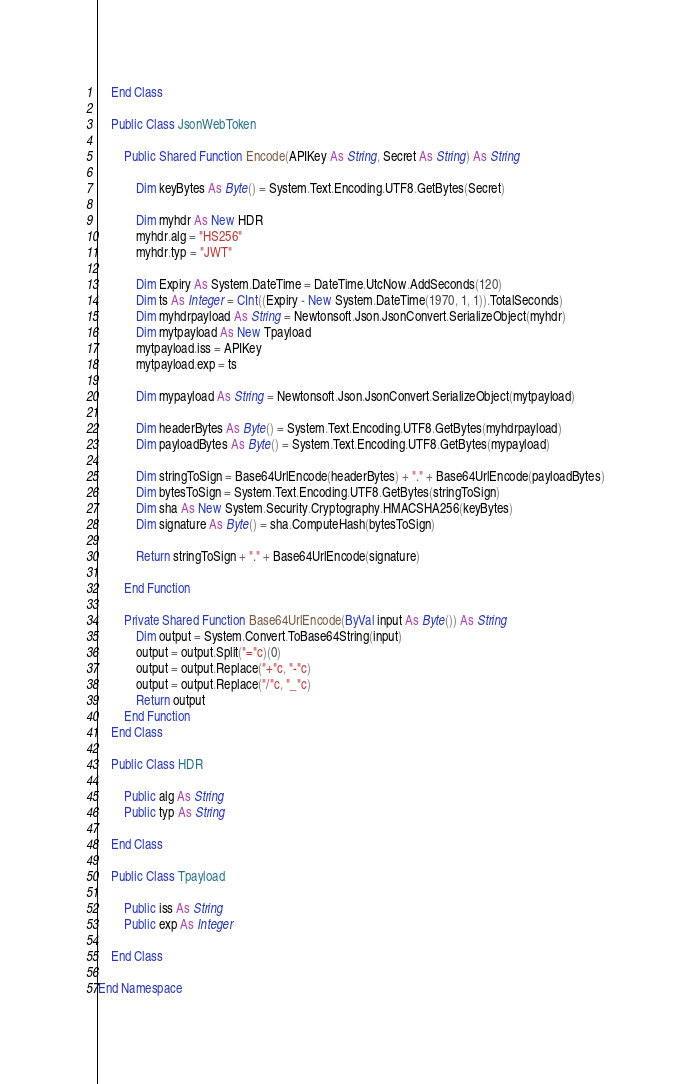<code> <loc_0><loc_0><loc_500><loc_500><_VisualBasic_>
    End Class

    Public Class JsonWebToken

        Public Shared Function Encode(APIKey As String, Secret As String) As String

            Dim keyBytes As Byte() = System.Text.Encoding.UTF8.GetBytes(Secret)

            Dim myhdr As New HDR
            myhdr.alg = "HS256"
            myhdr.typ = "JWT"

            Dim Expiry As System.DateTime = DateTime.UtcNow.AddSeconds(120)
            Dim ts As Integer = CInt((Expiry - New System.DateTime(1970, 1, 1)).TotalSeconds)
            Dim myhdrpayload As String = Newtonsoft.Json.JsonConvert.SerializeObject(myhdr)
            Dim mytpayload As New Tpayload
            mytpayload.iss = APIKey
            mytpayload.exp = ts

            Dim mypayload As String = Newtonsoft.Json.JsonConvert.SerializeObject(mytpayload)

            Dim headerBytes As Byte() = System.Text.Encoding.UTF8.GetBytes(myhdrpayload)
            Dim payloadBytes As Byte() = System.Text.Encoding.UTF8.GetBytes(mypayload)

            Dim stringToSign = Base64UrlEncode(headerBytes) + "." + Base64UrlEncode(payloadBytes)
            Dim bytesToSign = System.Text.Encoding.UTF8.GetBytes(stringToSign)
            Dim sha As New System.Security.Cryptography.HMACSHA256(keyBytes)
            Dim signature As Byte() = sha.ComputeHash(bytesToSign)

            Return stringToSign + "." + Base64UrlEncode(signature)

        End Function

        Private Shared Function Base64UrlEncode(ByVal input As Byte()) As String
            Dim output = System.Convert.ToBase64String(input)
            output = output.Split("="c)(0)
            output = output.Replace("+"c, "-"c)
            output = output.Replace("/"c, "_"c)
            Return output
        End Function
    End Class

    Public Class HDR

        Public alg As String
        Public typ As String

    End Class

    Public Class Tpayload

        Public iss As String
        Public exp As Integer

    End Class

End Namespace</code> 